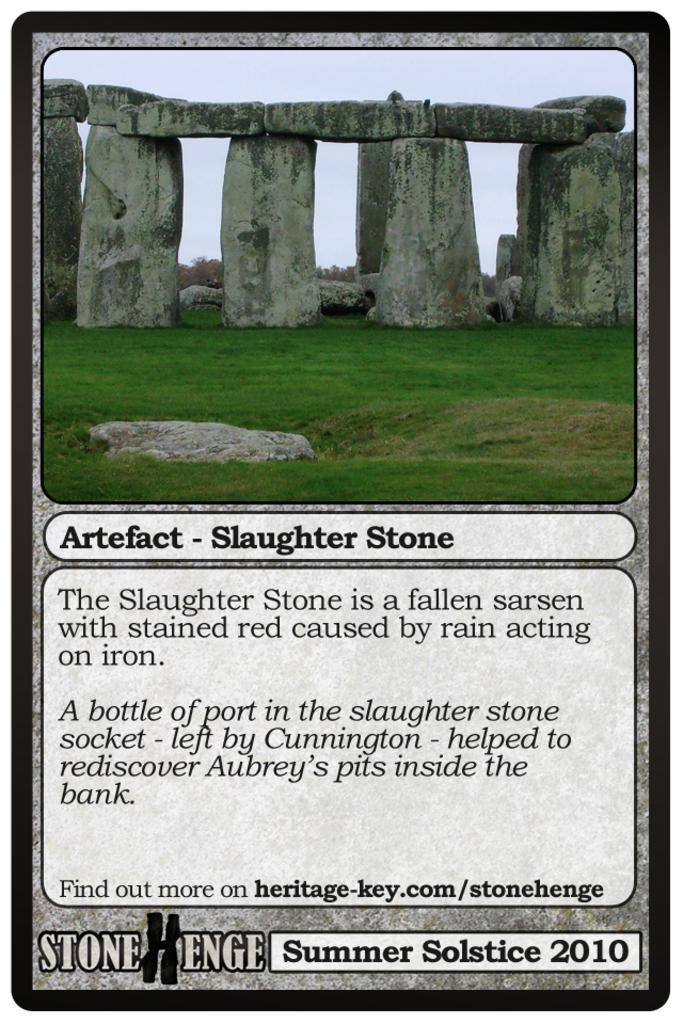How would you summarize this image in a sentence or two? In this image there is a poster having a picture and some text on it. In the picture there is a grassland having few rocks on it. Top of image there is sky. Bottom of image there is some text. 